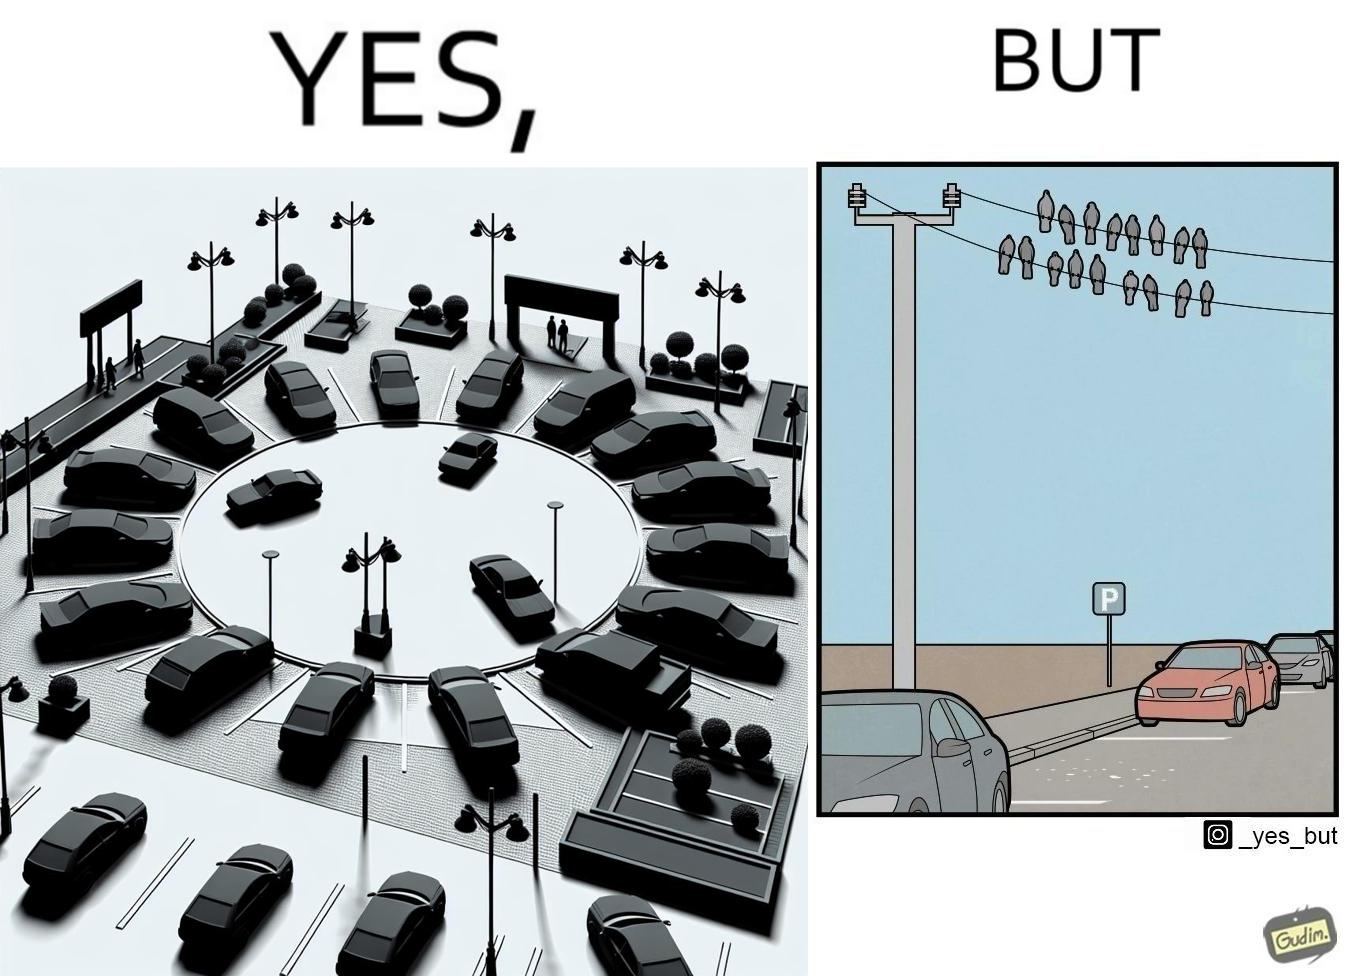Is this a satirical image? Yes, this image is satirical. 